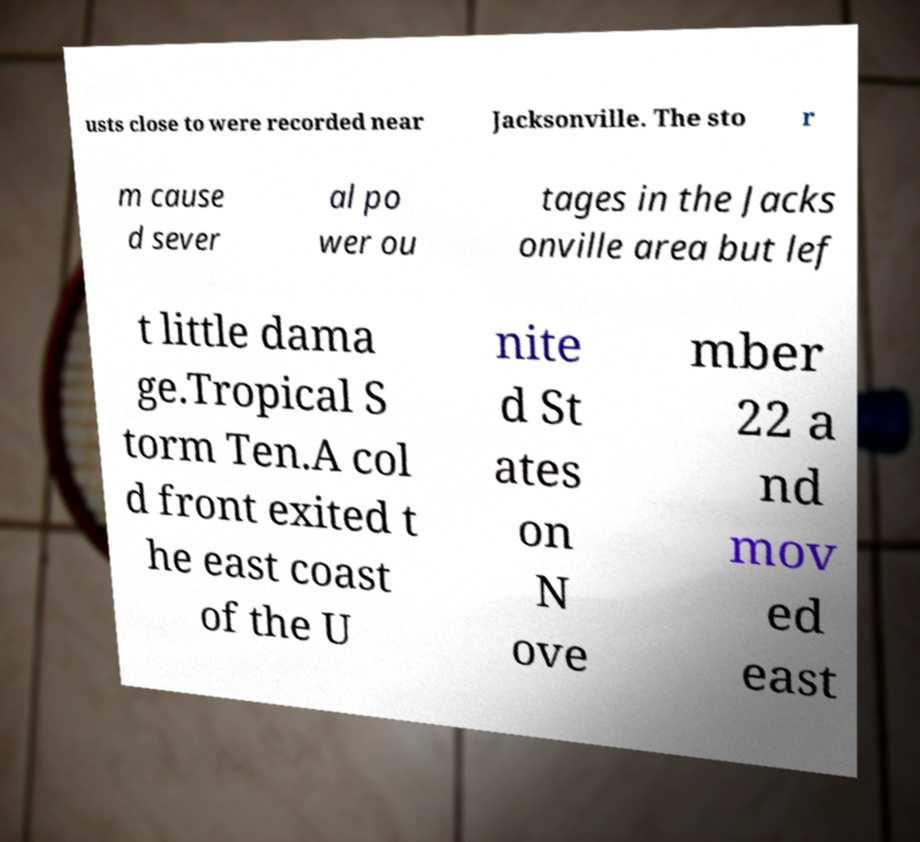Could you assist in decoding the text presented in this image and type it out clearly? usts close to were recorded near Jacksonville. The sto r m cause d sever al po wer ou tages in the Jacks onville area but lef t little dama ge.Tropical S torm Ten.A col d front exited t he east coast of the U nite d St ates on N ove mber 22 a nd mov ed east 